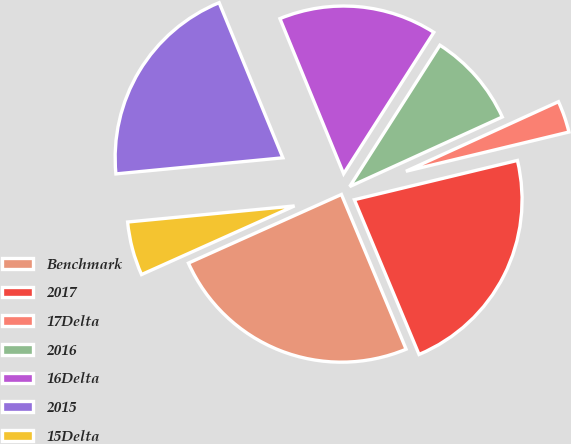Convert chart. <chart><loc_0><loc_0><loc_500><loc_500><pie_chart><fcel>Benchmark<fcel>2017<fcel>17Delta<fcel>2016<fcel>16Delta<fcel>2015<fcel>15Delta<nl><fcel>24.59%<fcel>22.46%<fcel>3.05%<fcel>9.15%<fcel>15.24%<fcel>20.33%<fcel>5.18%<nl></chart> 